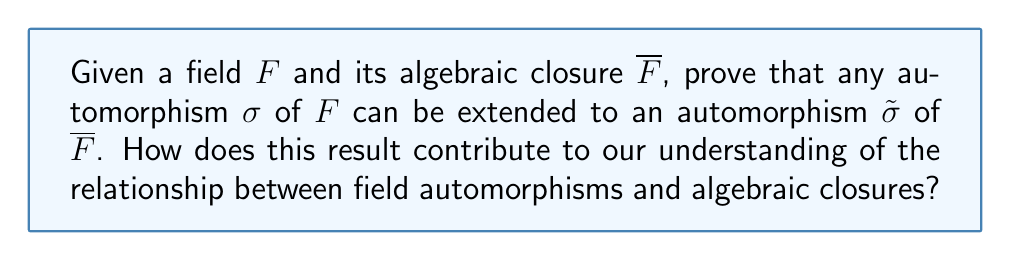Show me your answer to this math problem. Let's approach this proof step-by-step:

1) First, recall that an algebraic closure $\overline{F}$ of a field $F$ is an algebraic extension of $F$ that is algebraically closed.

2) Let $\sigma$ be an automorphism of $F$. We need to construct an automorphism $\tilde{\sigma}$ of $\overline{F}$ that extends $\sigma$.

3) Consider an arbitrary element $\alpha \in \overline{F}$. Since $\overline{F}$ is an algebraic extension of $F$, $\alpha$ is algebraic over $F$.

4) Let $f(X) = a_nX^n + a_{n-1}X^{n-1} + \cdots + a_1X + a_0$ be the minimal polynomial of $\alpha$ over $F$.

5) Apply $\sigma$ to the coefficients of $f(X)$ to get a new polynomial:
   $$g(X) = \sigma(a_n)X^n + \sigma(a_{n-1})X^{n-1} + \cdots + \sigma(a_1)X + \sigma(a_0)$$

6) Since $\sigma$ is an automorphism of $F$, $g(X)$ is also irreducible over $F$.

7) As $\overline{F}$ is algebraically closed, $g(X)$ has a root $\beta$ in $\overline{F}$.

8) Define $\tilde{\sigma}(\alpha) = \beta$.

9) Extend this definition to all of $\overline{F}$ using the fact that every element of $\overline{F}$ is algebraic over $F$.

10) It can be shown that $\tilde{\sigma}$ is well-defined, injective, and surjective, making it an automorphism of $\overline{F}$.

11) By construction, $\tilde{\sigma}$ agrees with $\sigma$ on $F$, so it is indeed an extension of $\sigma$.

This result demonstrates a deep connection between field automorphisms and algebraic closures. It shows that the structure of the base field $F$, as captured by its automorphisms, can be "lifted" to the algebraic closure $\overline{F}$. This preserves important algebraic properties and relationships between $F$ and $\overline{F}$.
Answer: Every automorphism of $F$ extends to an automorphism of $\overline{F}$. 